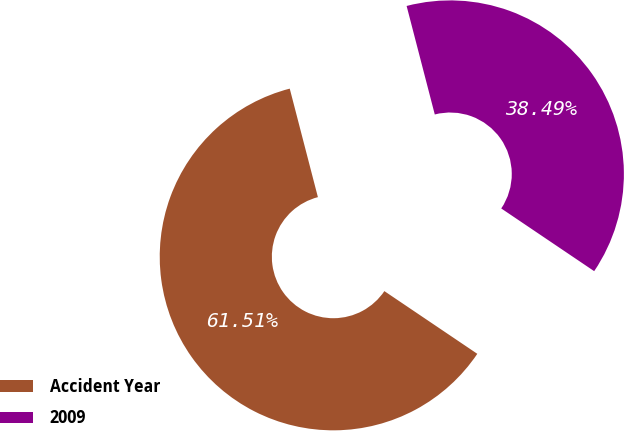Convert chart. <chart><loc_0><loc_0><loc_500><loc_500><pie_chart><fcel>Accident Year<fcel>2009<nl><fcel>61.51%<fcel>38.49%<nl></chart> 